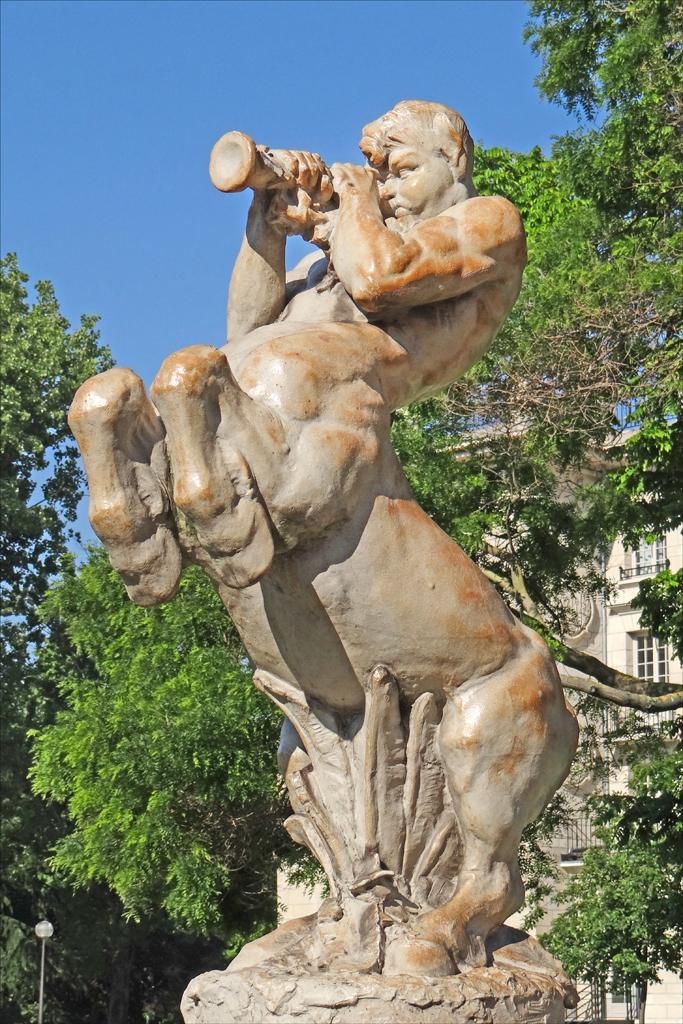Can you describe this image briefly? In this picture I can see a statue, a building, trees, and in the background there is sky. 